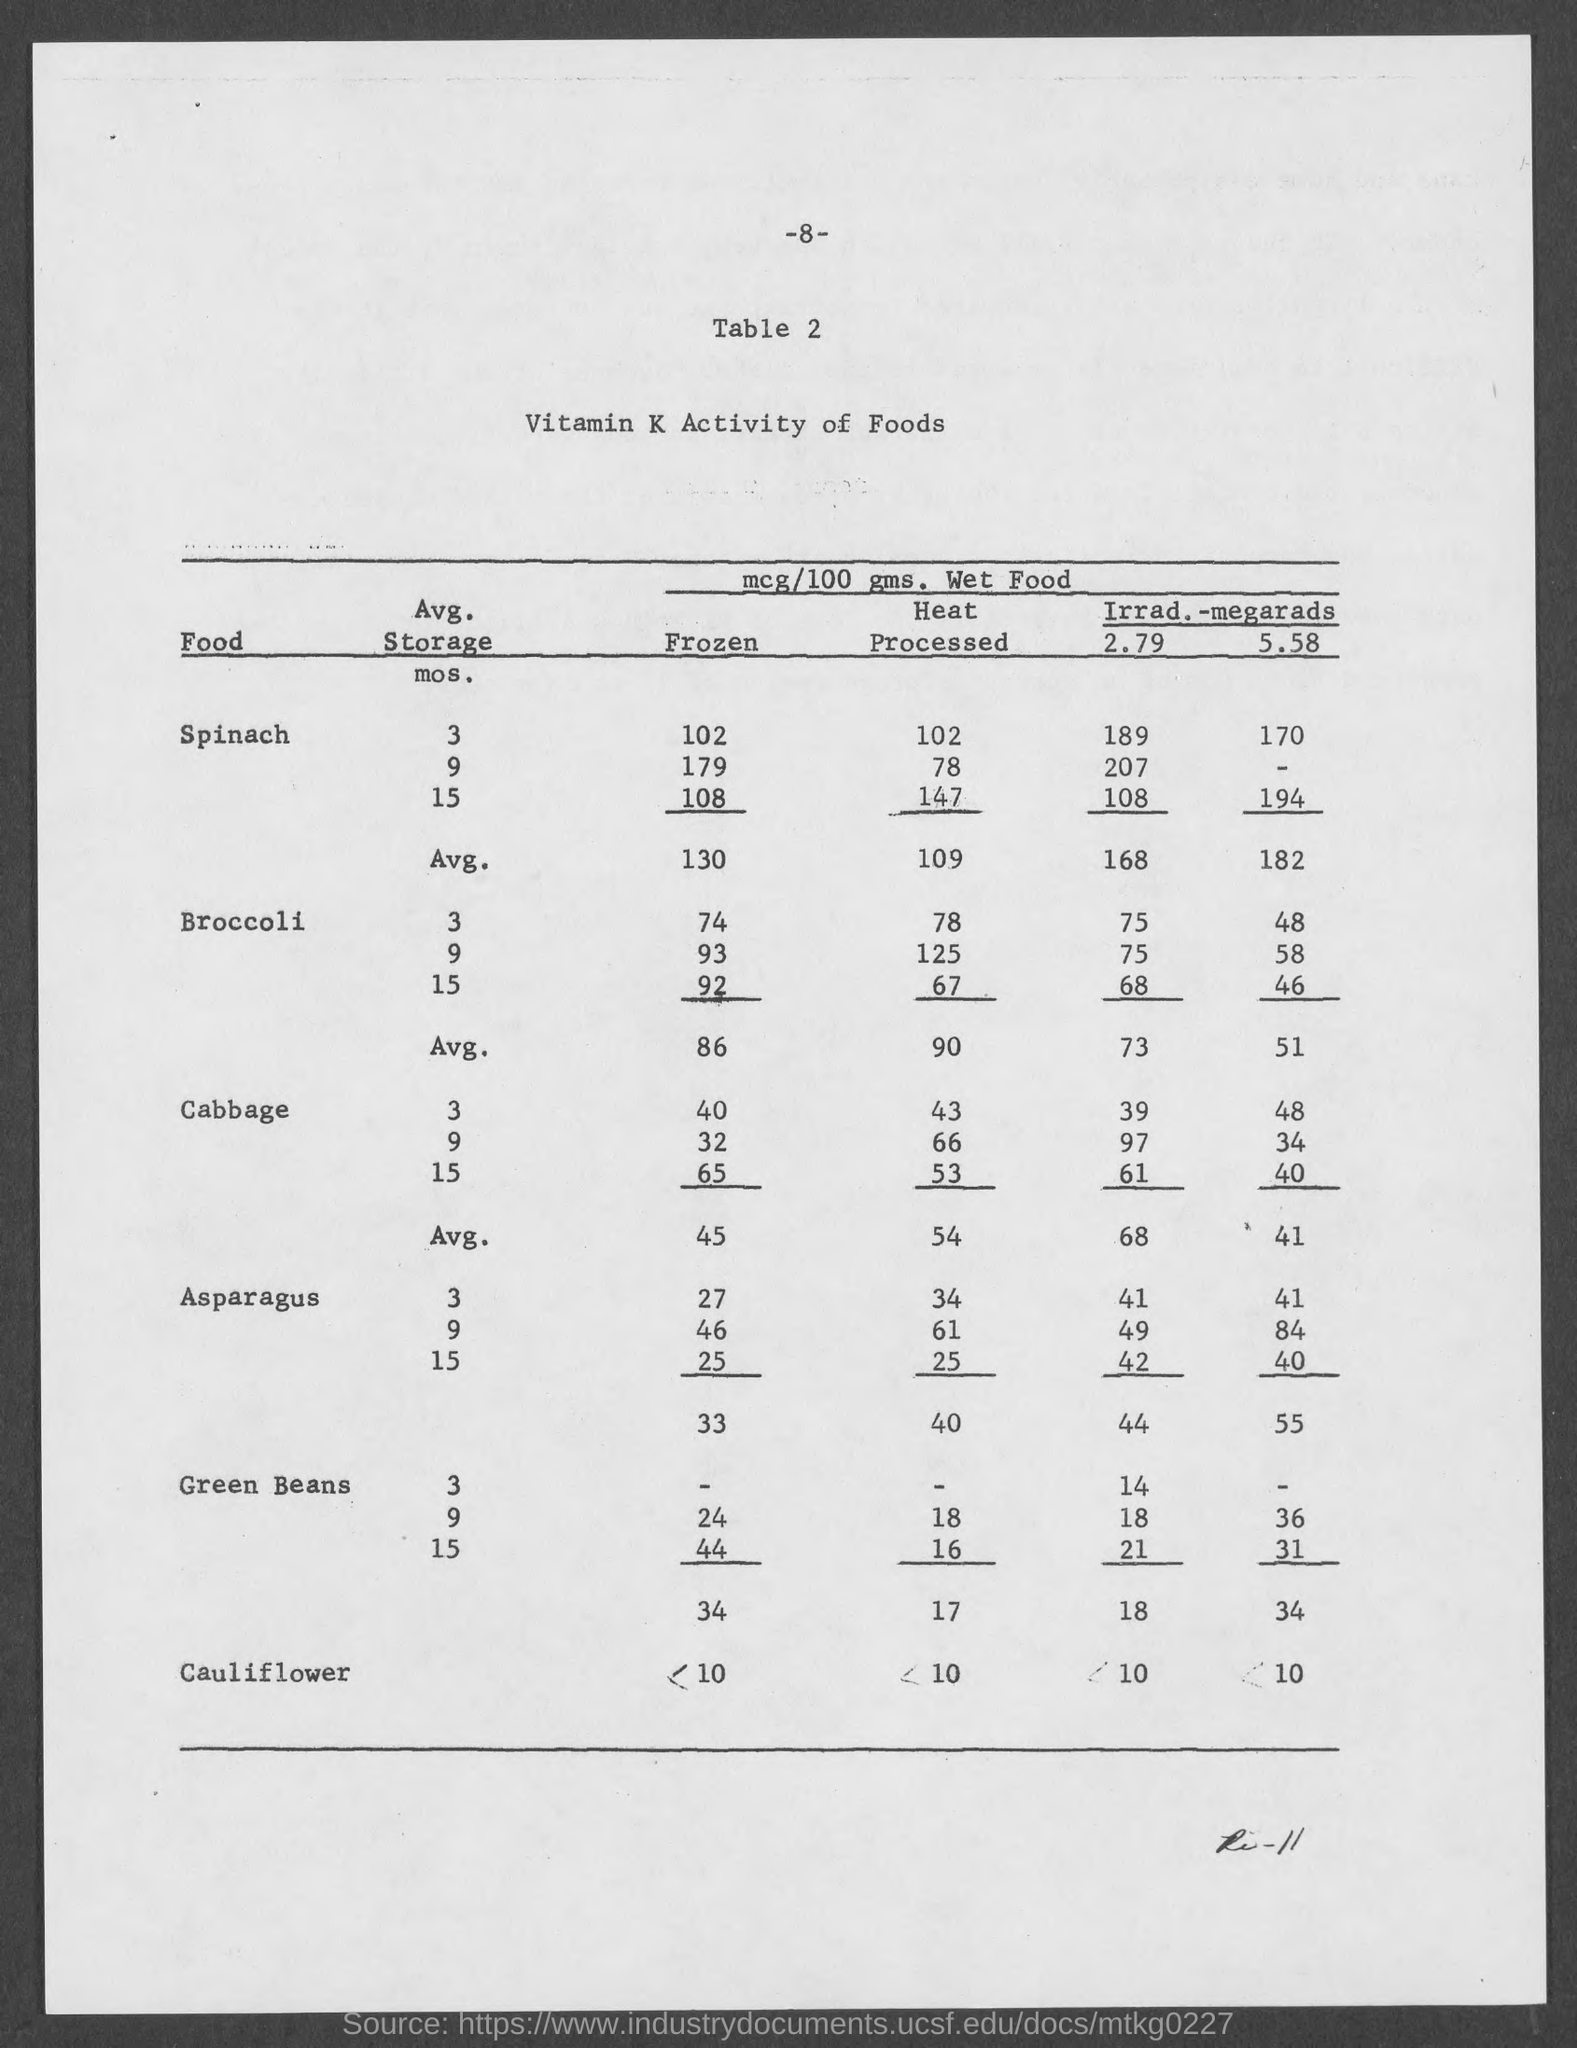What is the page number at top of the page?
Provide a succinct answer. -8-. What is the title of the table ?
Keep it short and to the point. Vitamin K activity of Foods. 